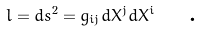Convert formula to latex. <formula><loc_0><loc_0><loc_500><loc_500>l = d s ^ { 2 } = g _ { i j } d X ^ { j } d X ^ { i } \text { \ \ .}</formula> 